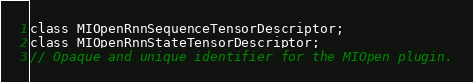<code> <loc_0><loc_0><loc_500><loc_500><_C_>class MIOpenRnnSequenceTensorDescriptor;
class MIOpenRnnStateTensorDescriptor;
// Opaque and unique identifier for the MIOpen plugin.</code> 